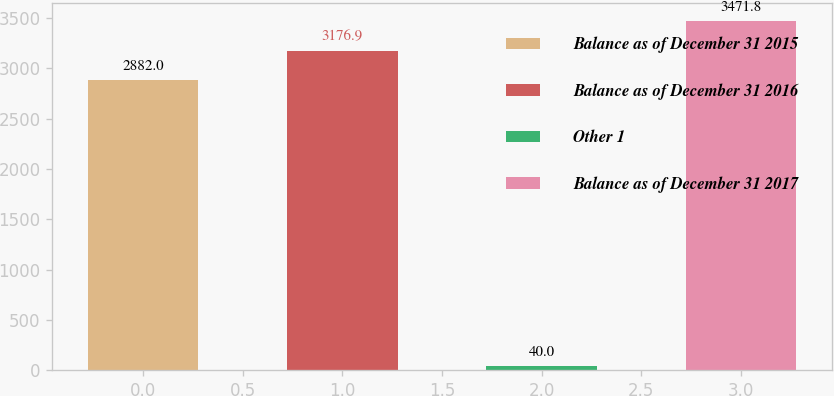Convert chart to OTSL. <chart><loc_0><loc_0><loc_500><loc_500><bar_chart><fcel>Balance as of December 31 2015<fcel>Balance as of December 31 2016<fcel>Other 1<fcel>Balance as of December 31 2017<nl><fcel>2882<fcel>3176.9<fcel>40<fcel>3471.8<nl></chart> 